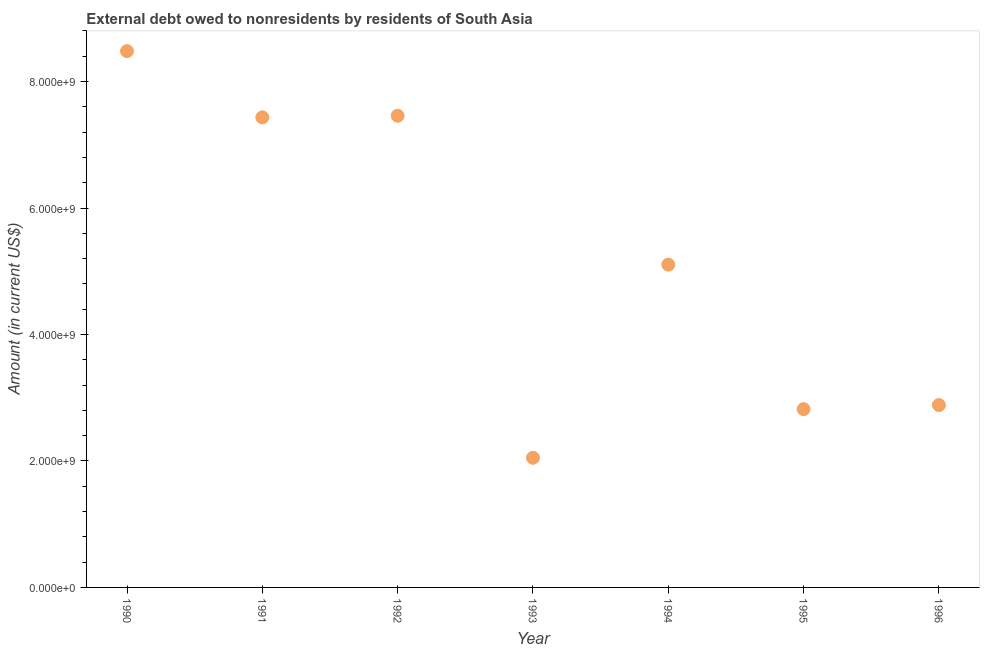What is the debt in 1994?
Provide a succinct answer. 5.10e+09. Across all years, what is the maximum debt?
Your answer should be very brief. 8.48e+09. Across all years, what is the minimum debt?
Provide a short and direct response. 2.05e+09. In which year was the debt minimum?
Provide a succinct answer. 1993. What is the sum of the debt?
Your response must be concise. 3.62e+1. What is the difference between the debt in 1991 and 1994?
Provide a short and direct response. 2.33e+09. What is the average debt per year?
Make the answer very short. 5.18e+09. What is the median debt?
Provide a succinct answer. 5.10e+09. Do a majority of the years between 1993 and 1994 (inclusive) have debt greater than 1200000000 US$?
Make the answer very short. Yes. What is the ratio of the debt in 1990 to that in 1993?
Keep it short and to the point. 4.14. What is the difference between the highest and the second highest debt?
Make the answer very short. 1.02e+09. What is the difference between the highest and the lowest debt?
Ensure brevity in your answer.  6.43e+09. In how many years, is the debt greater than the average debt taken over all years?
Offer a terse response. 3. How many years are there in the graph?
Your answer should be compact. 7. What is the difference between two consecutive major ticks on the Y-axis?
Your response must be concise. 2.00e+09. Are the values on the major ticks of Y-axis written in scientific E-notation?
Provide a succinct answer. Yes. Does the graph contain any zero values?
Give a very brief answer. No. Does the graph contain grids?
Offer a very short reply. No. What is the title of the graph?
Your response must be concise. External debt owed to nonresidents by residents of South Asia. What is the Amount (in current US$) in 1990?
Give a very brief answer. 8.48e+09. What is the Amount (in current US$) in 1991?
Provide a succinct answer. 7.43e+09. What is the Amount (in current US$) in 1992?
Keep it short and to the point. 7.46e+09. What is the Amount (in current US$) in 1993?
Give a very brief answer. 2.05e+09. What is the Amount (in current US$) in 1994?
Ensure brevity in your answer.  5.10e+09. What is the Amount (in current US$) in 1995?
Offer a terse response. 2.82e+09. What is the Amount (in current US$) in 1996?
Give a very brief answer. 2.88e+09. What is the difference between the Amount (in current US$) in 1990 and 1991?
Keep it short and to the point. 1.05e+09. What is the difference between the Amount (in current US$) in 1990 and 1992?
Your answer should be compact. 1.02e+09. What is the difference between the Amount (in current US$) in 1990 and 1993?
Give a very brief answer. 6.43e+09. What is the difference between the Amount (in current US$) in 1990 and 1994?
Give a very brief answer. 3.38e+09. What is the difference between the Amount (in current US$) in 1990 and 1995?
Your answer should be compact. 5.66e+09. What is the difference between the Amount (in current US$) in 1990 and 1996?
Your answer should be very brief. 5.60e+09. What is the difference between the Amount (in current US$) in 1991 and 1992?
Ensure brevity in your answer.  -2.57e+07. What is the difference between the Amount (in current US$) in 1991 and 1993?
Provide a succinct answer. 5.38e+09. What is the difference between the Amount (in current US$) in 1991 and 1994?
Ensure brevity in your answer.  2.33e+09. What is the difference between the Amount (in current US$) in 1991 and 1995?
Provide a short and direct response. 4.61e+09. What is the difference between the Amount (in current US$) in 1991 and 1996?
Your response must be concise. 4.55e+09. What is the difference between the Amount (in current US$) in 1992 and 1993?
Provide a succinct answer. 5.41e+09. What is the difference between the Amount (in current US$) in 1992 and 1994?
Offer a very short reply. 2.35e+09. What is the difference between the Amount (in current US$) in 1992 and 1995?
Provide a succinct answer. 4.64e+09. What is the difference between the Amount (in current US$) in 1992 and 1996?
Your answer should be very brief. 4.58e+09. What is the difference between the Amount (in current US$) in 1993 and 1994?
Give a very brief answer. -3.05e+09. What is the difference between the Amount (in current US$) in 1993 and 1995?
Your answer should be compact. -7.69e+08. What is the difference between the Amount (in current US$) in 1993 and 1996?
Provide a short and direct response. -8.34e+08. What is the difference between the Amount (in current US$) in 1994 and 1995?
Your response must be concise. 2.29e+09. What is the difference between the Amount (in current US$) in 1994 and 1996?
Keep it short and to the point. 2.22e+09. What is the difference between the Amount (in current US$) in 1995 and 1996?
Offer a very short reply. -6.47e+07. What is the ratio of the Amount (in current US$) in 1990 to that in 1991?
Your response must be concise. 1.14. What is the ratio of the Amount (in current US$) in 1990 to that in 1992?
Your answer should be compact. 1.14. What is the ratio of the Amount (in current US$) in 1990 to that in 1993?
Your answer should be compact. 4.14. What is the ratio of the Amount (in current US$) in 1990 to that in 1994?
Ensure brevity in your answer.  1.66. What is the ratio of the Amount (in current US$) in 1990 to that in 1995?
Your response must be concise. 3.01. What is the ratio of the Amount (in current US$) in 1990 to that in 1996?
Your answer should be very brief. 2.94. What is the ratio of the Amount (in current US$) in 1991 to that in 1993?
Offer a very short reply. 3.62. What is the ratio of the Amount (in current US$) in 1991 to that in 1994?
Ensure brevity in your answer.  1.46. What is the ratio of the Amount (in current US$) in 1991 to that in 1995?
Your response must be concise. 2.64. What is the ratio of the Amount (in current US$) in 1991 to that in 1996?
Give a very brief answer. 2.58. What is the ratio of the Amount (in current US$) in 1992 to that in 1993?
Offer a terse response. 3.64. What is the ratio of the Amount (in current US$) in 1992 to that in 1994?
Your answer should be very brief. 1.46. What is the ratio of the Amount (in current US$) in 1992 to that in 1995?
Your answer should be very brief. 2.65. What is the ratio of the Amount (in current US$) in 1992 to that in 1996?
Your response must be concise. 2.59. What is the ratio of the Amount (in current US$) in 1993 to that in 1994?
Offer a terse response. 0.4. What is the ratio of the Amount (in current US$) in 1993 to that in 1995?
Your answer should be very brief. 0.73. What is the ratio of the Amount (in current US$) in 1993 to that in 1996?
Provide a succinct answer. 0.71. What is the ratio of the Amount (in current US$) in 1994 to that in 1995?
Offer a terse response. 1.81. What is the ratio of the Amount (in current US$) in 1994 to that in 1996?
Ensure brevity in your answer.  1.77. What is the ratio of the Amount (in current US$) in 1995 to that in 1996?
Provide a succinct answer. 0.98. 